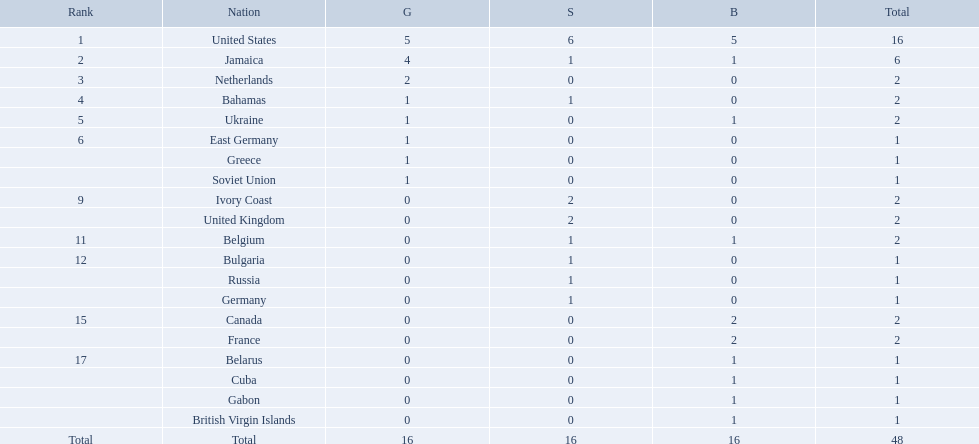Which nations took home at least one gold medal in the 60 metres competition? United States, Jamaica, Netherlands, Bahamas, Ukraine, East Germany, Greece, Soviet Union. Of these nations, which one won the most gold medals? United States. Which countries competed in the 60 meters competition? United States, Jamaica, Netherlands, Bahamas, Ukraine, East Germany, Greece, Soviet Union, Ivory Coast, United Kingdom, Belgium, Bulgaria, Russia, Germany, Canada, France, Belarus, Cuba, Gabon, British Virgin Islands. And how many gold medals did they win? 5, 4, 2, 1, 1, 1, 1, 1, 0, 0, 0, 0, 0, 0, 0, 0, 0, 0, 0, 0. Of those countries, which won the second highest number gold medals? Jamaica. 